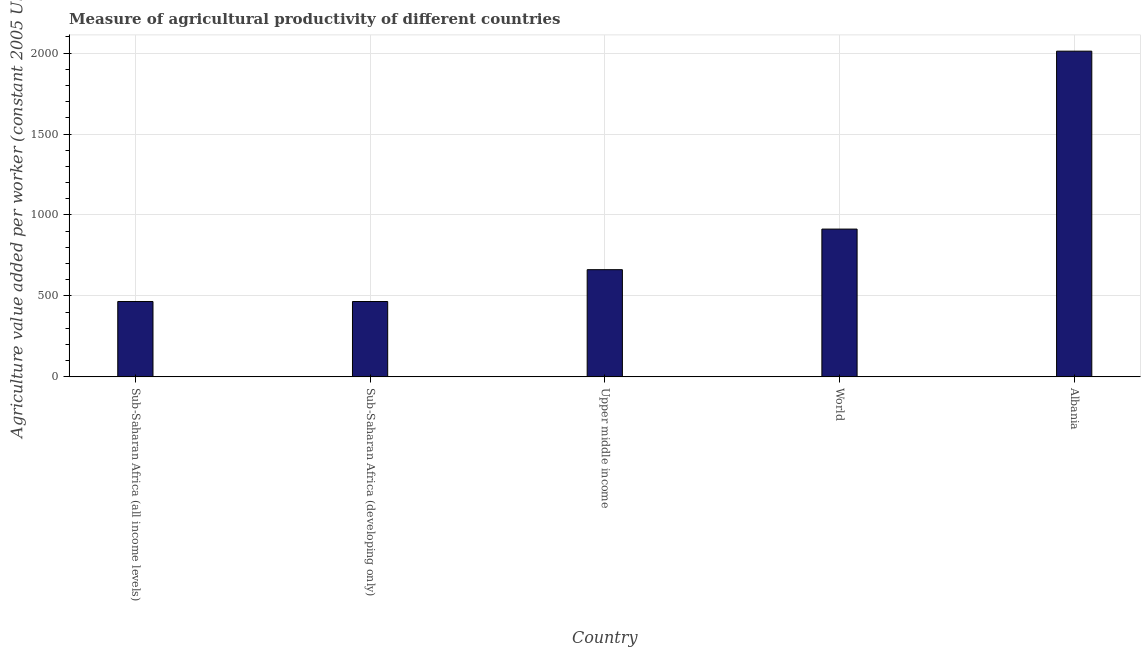Does the graph contain grids?
Provide a succinct answer. Yes. What is the title of the graph?
Ensure brevity in your answer.  Measure of agricultural productivity of different countries. What is the label or title of the Y-axis?
Your answer should be very brief. Agriculture value added per worker (constant 2005 US$). What is the agriculture value added per worker in Upper middle income?
Your answer should be compact. 662.09. Across all countries, what is the maximum agriculture value added per worker?
Give a very brief answer. 2011.83. Across all countries, what is the minimum agriculture value added per worker?
Provide a short and direct response. 465.53. In which country was the agriculture value added per worker maximum?
Ensure brevity in your answer.  Albania. In which country was the agriculture value added per worker minimum?
Ensure brevity in your answer.  Sub-Saharan Africa (developing only). What is the sum of the agriculture value added per worker?
Your answer should be compact. 4517.95. What is the difference between the agriculture value added per worker in Sub-Saharan Africa (all income levels) and World?
Provide a succinct answer. -447.23. What is the average agriculture value added per worker per country?
Make the answer very short. 903.59. What is the median agriculture value added per worker?
Your response must be concise. 662.09. In how many countries, is the agriculture value added per worker greater than 900 US$?
Your answer should be compact. 2. What is the ratio of the agriculture value added per worker in Sub-Saharan Africa (developing only) to that in World?
Give a very brief answer. 0.51. What is the difference between the highest and the second highest agriculture value added per worker?
Offer a terse response. 1098.97. Is the sum of the agriculture value added per worker in Sub-Saharan Africa (all income levels) and Upper middle income greater than the maximum agriculture value added per worker across all countries?
Your response must be concise. No. What is the difference between the highest and the lowest agriculture value added per worker?
Provide a short and direct response. 1546.3. Are all the bars in the graph horizontal?
Your answer should be very brief. No. What is the Agriculture value added per worker (constant 2005 US$) in Sub-Saharan Africa (all income levels)?
Make the answer very short. 465.63. What is the Agriculture value added per worker (constant 2005 US$) in Sub-Saharan Africa (developing only)?
Keep it short and to the point. 465.53. What is the Agriculture value added per worker (constant 2005 US$) in Upper middle income?
Make the answer very short. 662.09. What is the Agriculture value added per worker (constant 2005 US$) in World?
Your answer should be very brief. 912.86. What is the Agriculture value added per worker (constant 2005 US$) in Albania?
Provide a succinct answer. 2011.83. What is the difference between the Agriculture value added per worker (constant 2005 US$) in Sub-Saharan Africa (all income levels) and Sub-Saharan Africa (developing only)?
Your answer should be very brief. 0.1. What is the difference between the Agriculture value added per worker (constant 2005 US$) in Sub-Saharan Africa (all income levels) and Upper middle income?
Offer a very short reply. -196.46. What is the difference between the Agriculture value added per worker (constant 2005 US$) in Sub-Saharan Africa (all income levels) and World?
Give a very brief answer. -447.23. What is the difference between the Agriculture value added per worker (constant 2005 US$) in Sub-Saharan Africa (all income levels) and Albania?
Provide a short and direct response. -1546.2. What is the difference between the Agriculture value added per worker (constant 2005 US$) in Sub-Saharan Africa (developing only) and Upper middle income?
Provide a short and direct response. -196.55. What is the difference between the Agriculture value added per worker (constant 2005 US$) in Sub-Saharan Africa (developing only) and World?
Ensure brevity in your answer.  -447.33. What is the difference between the Agriculture value added per worker (constant 2005 US$) in Sub-Saharan Africa (developing only) and Albania?
Provide a succinct answer. -1546.3. What is the difference between the Agriculture value added per worker (constant 2005 US$) in Upper middle income and World?
Offer a terse response. -250.77. What is the difference between the Agriculture value added per worker (constant 2005 US$) in Upper middle income and Albania?
Your answer should be compact. -1349.75. What is the difference between the Agriculture value added per worker (constant 2005 US$) in World and Albania?
Make the answer very short. -1098.97. What is the ratio of the Agriculture value added per worker (constant 2005 US$) in Sub-Saharan Africa (all income levels) to that in Upper middle income?
Give a very brief answer. 0.7. What is the ratio of the Agriculture value added per worker (constant 2005 US$) in Sub-Saharan Africa (all income levels) to that in World?
Your answer should be compact. 0.51. What is the ratio of the Agriculture value added per worker (constant 2005 US$) in Sub-Saharan Africa (all income levels) to that in Albania?
Your answer should be very brief. 0.23. What is the ratio of the Agriculture value added per worker (constant 2005 US$) in Sub-Saharan Africa (developing only) to that in Upper middle income?
Ensure brevity in your answer.  0.7. What is the ratio of the Agriculture value added per worker (constant 2005 US$) in Sub-Saharan Africa (developing only) to that in World?
Offer a very short reply. 0.51. What is the ratio of the Agriculture value added per worker (constant 2005 US$) in Sub-Saharan Africa (developing only) to that in Albania?
Your response must be concise. 0.23. What is the ratio of the Agriculture value added per worker (constant 2005 US$) in Upper middle income to that in World?
Provide a short and direct response. 0.72. What is the ratio of the Agriculture value added per worker (constant 2005 US$) in Upper middle income to that in Albania?
Offer a terse response. 0.33. What is the ratio of the Agriculture value added per worker (constant 2005 US$) in World to that in Albania?
Give a very brief answer. 0.45. 